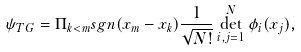<formula> <loc_0><loc_0><loc_500><loc_500>\psi _ { T G } = \Pi _ { k < m } s g n ( x _ { m } - x _ { k } ) \frac { 1 } { \sqrt { N ! } } \det _ { i , j = 1 } ^ { N } \phi _ { i } ( x _ { j } ) ,</formula> 